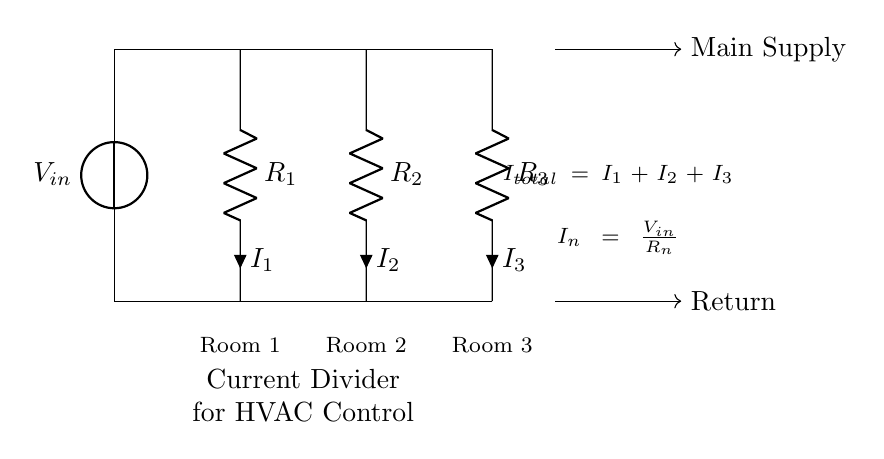What does each resistor represent? The resistors in the diagram represent the resistance in different rooms, thus helping in current distribution to each.
Answer: Room 1, Room 2, Room 3 What is the total current in the circuit? The total current is the sum of the currents through each resistor, calculated as I total = I1 + I2 + I3.
Answer: I total How is the current through each room calculated? The current through each resistor is calculated using Ohm's Law, where the current for each resistor (I_n) is equal to the voltage input (V_in) divided by the resistance (R_n).
Answer: V_in / R_n What is the effect of increasing R2's resistance? Increasing the resistance of R2 will result in a decrease in the current through Room 2, affecting temperature regulation in that room.
Answer: Decrease current in Room 2 What signifies ‘main supply’ and ‘return’ in the circuit? The main supply is where the voltage input comes from, while the return represents where the current exits the system.
Answer: Main supply and return How do the resistors contribute to temperature regulation in HVAC? The resistors help divide the total current appropriately among the rooms, allowing for optimized temperature control based on the cooling/heating needs of each space.
Answer: Current distribution 